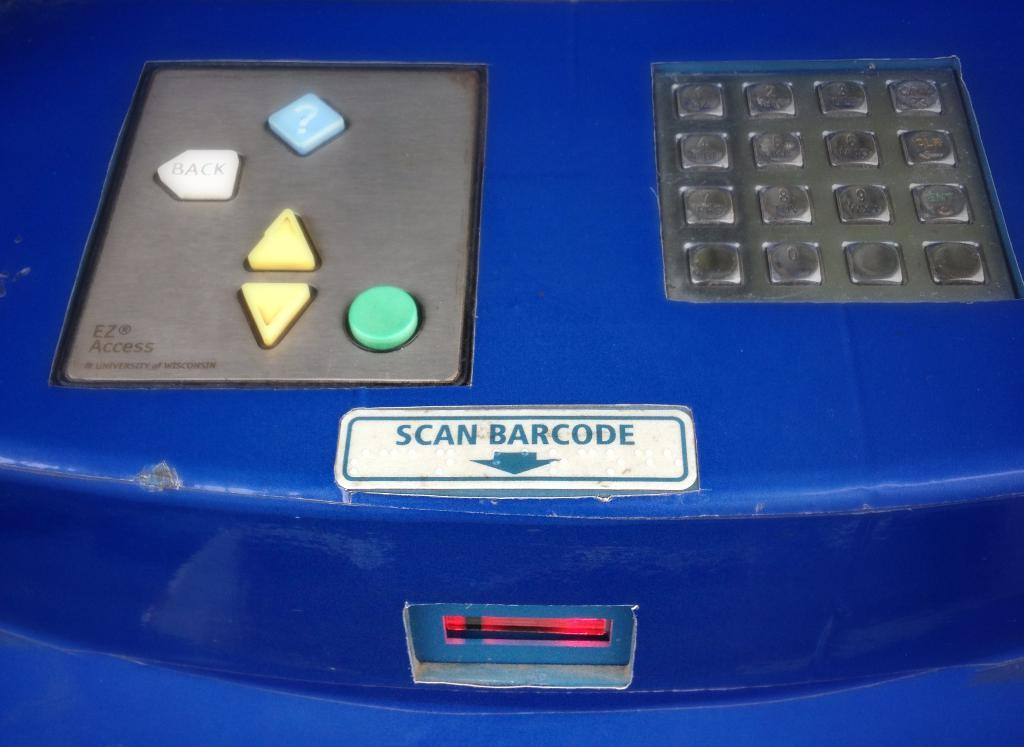What type of object is the machine in the image? The machine in the image has buttons and text on it. What can be found on the buttons of the machine? The buttons on the machine are visible in the image. What information is provided by the text on the machine? The text on the machine is also visible in the image. Where is the notebook located in the image? There is no notebook present in the image. Can you describe the island in the image? There is no island present in the image. 